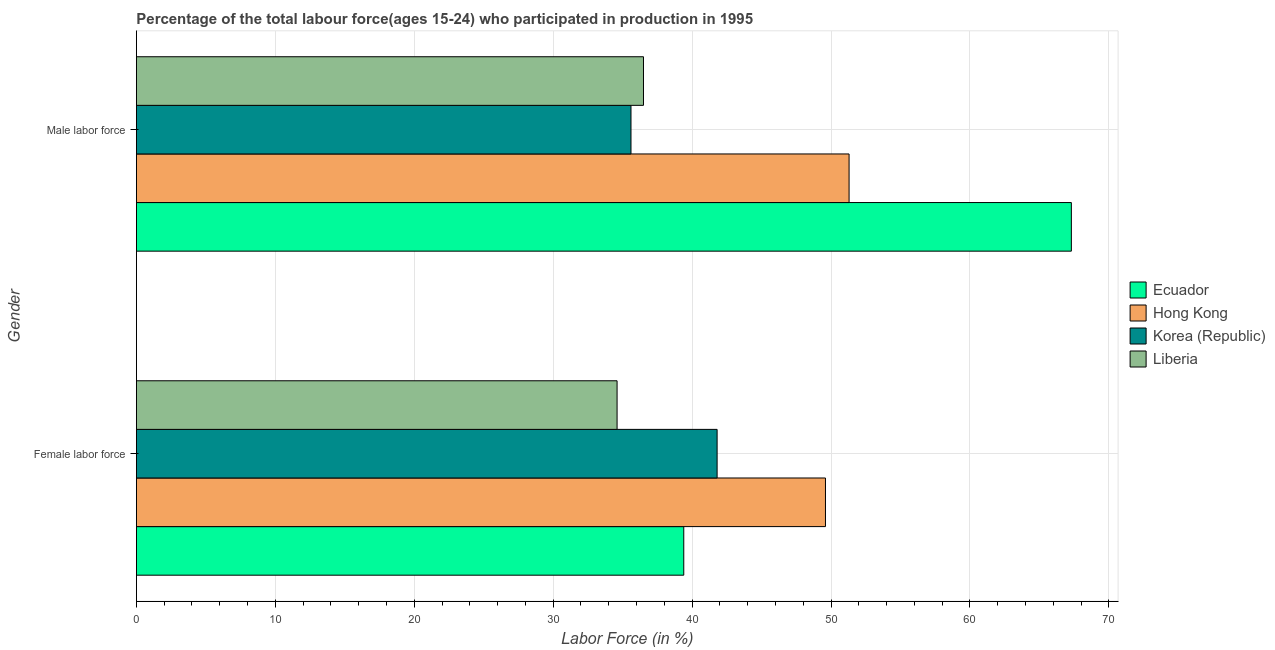How many different coloured bars are there?
Your response must be concise. 4. Are the number of bars per tick equal to the number of legend labels?
Your answer should be very brief. Yes. Are the number of bars on each tick of the Y-axis equal?
Your answer should be very brief. Yes. How many bars are there on the 2nd tick from the bottom?
Offer a very short reply. 4. What is the label of the 1st group of bars from the top?
Offer a terse response. Male labor force. What is the percentage of male labour force in Hong Kong?
Your answer should be very brief. 51.3. Across all countries, what is the maximum percentage of male labour force?
Keep it short and to the point. 67.3. Across all countries, what is the minimum percentage of male labour force?
Your answer should be very brief. 35.6. In which country was the percentage of male labour force maximum?
Provide a short and direct response. Ecuador. In which country was the percentage of female labor force minimum?
Ensure brevity in your answer.  Liberia. What is the total percentage of male labour force in the graph?
Keep it short and to the point. 190.7. What is the difference between the percentage of female labor force in Ecuador and the percentage of male labour force in Korea (Republic)?
Offer a very short reply. 3.8. What is the average percentage of male labour force per country?
Provide a succinct answer. 47.68. What is the difference between the percentage of female labor force and percentage of male labour force in Ecuador?
Offer a terse response. -27.9. What is the ratio of the percentage of female labor force in Korea (Republic) to that in Ecuador?
Provide a succinct answer. 1.06. Is the percentage of female labor force in Korea (Republic) less than that in Liberia?
Offer a very short reply. No. In how many countries, is the percentage of female labor force greater than the average percentage of female labor force taken over all countries?
Your answer should be compact. 2. What does the 1st bar from the top in Male labor force represents?
Ensure brevity in your answer.  Liberia. What does the 2nd bar from the bottom in Female labor force represents?
Keep it short and to the point. Hong Kong. How many countries are there in the graph?
Your answer should be very brief. 4. What is the difference between two consecutive major ticks on the X-axis?
Offer a terse response. 10. Are the values on the major ticks of X-axis written in scientific E-notation?
Your answer should be compact. No. Does the graph contain any zero values?
Offer a terse response. No. Does the graph contain grids?
Provide a succinct answer. Yes. How many legend labels are there?
Your answer should be compact. 4. What is the title of the graph?
Your answer should be compact. Percentage of the total labour force(ages 15-24) who participated in production in 1995. What is the label or title of the X-axis?
Offer a terse response. Labor Force (in %). What is the Labor Force (in %) of Ecuador in Female labor force?
Provide a succinct answer. 39.4. What is the Labor Force (in %) of Hong Kong in Female labor force?
Provide a succinct answer. 49.6. What is the Labor Force (in %) in Korea (Republic) in Female labor force?
Offer a very short reply. 41.8. What is the Labor Force (in %) in Liberia in Female labor force?
Provide a short and direct response. 34.6. What is the Labor Force (in %) of Ecuador in Male labor force?
Your response must be concise. 67.3. What is the Labor Force (in %) in Hong Kong in Male labor force?
Provide a succinct answer. 51.3. What is the Labor Force (in %) of Korea (Republic) in Male labor force?
Your answer should be very brief. 35.6. What is the Labor Force (in %) of Liberia in Male labor force?
Give a very brief answer. 36.5. Across all Gender, what is the maximum Labor Force (in %) of Ecuador?
Your response must be concise. 67.3. Across all Gender, what is the maximum Labor Force (in %) in Hong Kong?
Make the answer very short. 51.3. Across all Gender, what is the maximum Labor Force (in %) in Korea (Republic)?
Offer a very short reply. 41.8. Across all Gender, what is the maximum Labor Force (in %) of Liberia?
Keep it short and to the point. 36.5. Across all Gender, what is the minimum Labor Force (in %) of Ecuador?
Give a very brief answer. 39.4. Across all Gender, what is the minimum Labor Force (in %) in Hong Kong?
Your answer should be very brief. 49.6. Across all Gender, what is the minimum Labor Force (in %) in Korea (Republic)?
Your answer should be very brief. 35.6. Across all Gender, what is the minimum Labor Force (in %) in Liberia?
Offer a very short reply. 34.6. What is the total Labor Force (in %) in Ecuador in the graph?
Make the answer very short. 106.7. What is the total Labor Force (in %) in Hong Kong in the graph?
Ensure brevity in your answer.  100.9. What is the total Labor Force (in %) of Korea (Republic) in the graph?
Offer a terse response. 77.4. What is the total Labor Force (in %) of Liberia in the graph?
Make the answer very short. 71.1. What is the difference between the Labor Force (in %) in Ecuador in Female labor force and that in Male labor force?
Your answer should be very brief. -27.9. What is the difference between the Labor Force (in %) in Liberia in Female labor force and that in Male labor force?
Offer a very short reply. -1.9. What is the difference between the Labor Force (in %) of Ecuador in Female labor force and the Labor Force (in %) of Korea (Republic) in Male labor force?
Your answer should be compact. 3.8. What is the difference between the Labor Force (in %) in Ecuador in Female labor force and the Labor Force (in %) in Liberia in Male labor force?
Your answer should be very brief. 2.9. What is the difference between the Labor Force (in %) of Hong Kong in Female labor force and the Labor Force (in %) of Liberia in Male labor force?
Offer a terse response. 13.1. What is the difference between the Labor Force (in %) in Korea (Republic) in Female labor force and the Labor Force (in %) in Liberia in Male labor force?
Ensure brevity in your answer.  5.3. What is the average Labor Force (in %) of Ecuador per Gender?
Keep it short and to the point. 53.35. What is the average Labor Force (in %) of Hong Kong per Gender?
Give a very brief answer. 50.45. What is the average Labor Force (in %) of Korea (Republic) per Gender?
Offer a very short reply. 38.7. What is the average Labor Force (in %) in Liberia per Gender?
Offer a terse response. 35.55. What is the difference between the Labor Force (in %) in Hong Kong and Labor Force (in %) in Liberia in Female labor force?
Your answer should be very brief. 15. What is the difference between the Labor Force (in %) in Ecuador and Labor Force (in %) in Korea (Republic) in Male labor force?
Make the answer very short. 31.7. What is the difference between the Labor Force (in %) in Ecuador and Labor Force (in %) in Liberia in Male labor force?
Provide a short and direct response. 30.8. What is the difference between the Labor Force (in %) in Hong Kong and Labor Force (in %) in Liberia in Male labor force?
Make the answer very short. 14.8. What is the difference between the Labor Force (in %) in Korea (Republic) and Labor Force (in %) in Liberia in Male labor force?
Provide a short and direct response. -0.9. What is the ratio of the Labor Force (in %) of Ecuador in Female labor force to that in Male labor force?
Provide a succinct answer. 0.59. What is the ratio of the Labor Force (in %) in Hong Kong in Female labor force to that in Male labor force?
Your answer should be compact. 0.97. What is the ratio of the Labor Force (in %) in Korea (Republic) in Female labor force to that in Male labor force?
Offer a very short reply. 1.17. What is the ratio of the Labor Force (in %) in Liberia in Female labor force to that in Male labor force?
Your response must be concise. 0.95. What is the difference between the highest and the second highest Labor Force (in %) in Ecuador?
Your answer should be compact. 27.9. What is the difference between the highest and the second highest Labor Force (in %) in Hong Kong?
Offer a terse response. 1.7. What is the difference between the highest and the second highest Labor Force (in %) in Korea (Republic)?
Ensure brevity in your answer.  6.2. What is the difference between the highest and the second highest Labor Force (in %) of Liberia?
Offer a terse response. 1.9. What is the difference between the highest and the lowest Labor Force (in %) in Ecuador?
Your response must be concise. 27.9. What is the difference between the highest and the lowest Labor Force (in %) in Liberia?
Offer a very short reply. 1.9. 